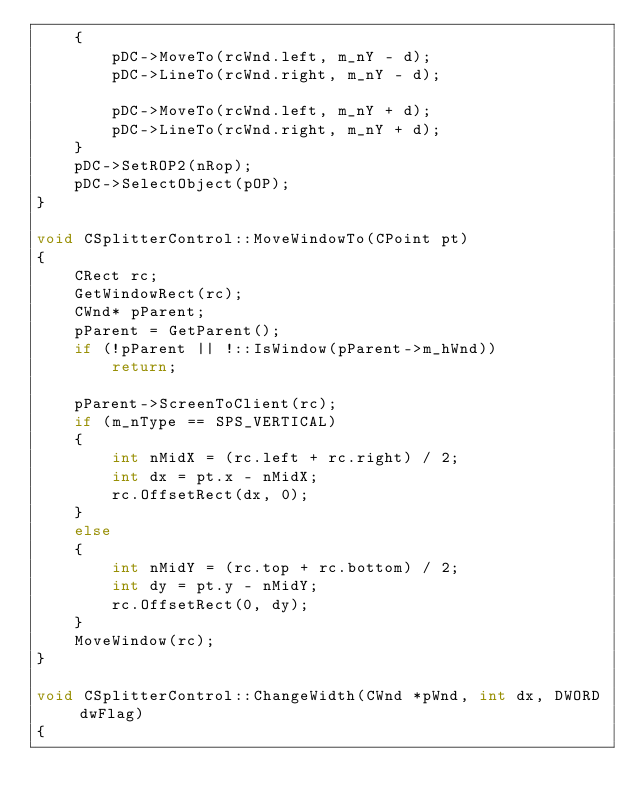Convert code to text. <code><loc_0><loc_0><loc_500><loc_500><_C++_>	{
		pDC->MoveTo(rcWnd.left, m_nY - d);
		pDC->LineTo(rcWnd.right, m_nY - d);

		pDC->MoveTo(rcWnd.left, m_nY + d);
		pDC->LineTo(rcWnd.right, m_nY + d);
	}
	pDC->SetROP2(nRop);
	pDC->SelectObject(pOP);
}

void CSplitterControl::MoveWindowTo(CPoint pt)
{
	CRect rc;
	GetWindowRect(rc);
	CWnd* pParent;
	pParent = GetParent();
	if (!pParent || !::IsWindow(pParent->m_hWnd))
		return;

	pParent->ScreenToClient(rc);
	if (m_nType == SPS_VERTICAL)
	{
		int nMidX = (rc.left + rc.right) / 2;
		int dx = pt.x - nMidX;
		rc.OffsetRect(dx, 0);
	}
	else
	{
		int nMidY = (rc.top + rc.bottom) / 2;
		int dy = pt.y - nMidY;
		rc.OffsetRect(0, dy);
	}
	MoveWindow(rc);
}

void CSplitterControl::ChangeWidth(CWnd *pWnd, int dx, DWORD dwFlag)
{</code> 